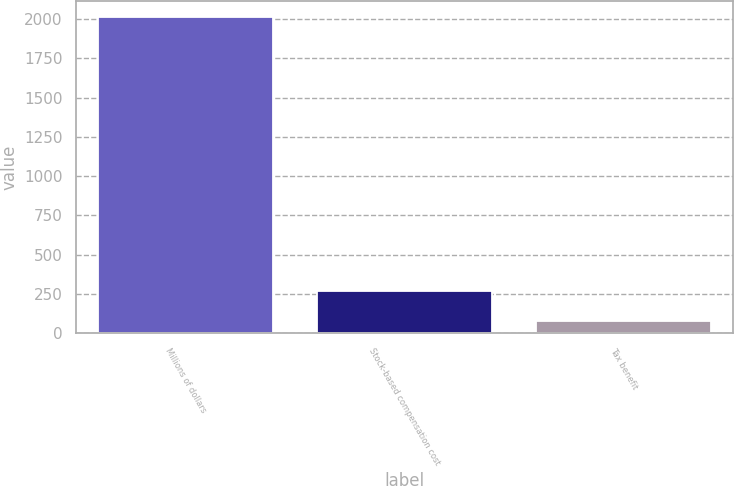Convert chart. <chart><loc_0><loc_0><loc_500><loc_500><bar_chart><fcel>Millions of dollars<fcel>Stock-based compensation cost<fcel>Tax benefit<nl><fcel>2016<fcel>270.9<fcel>77<nl></chart> 